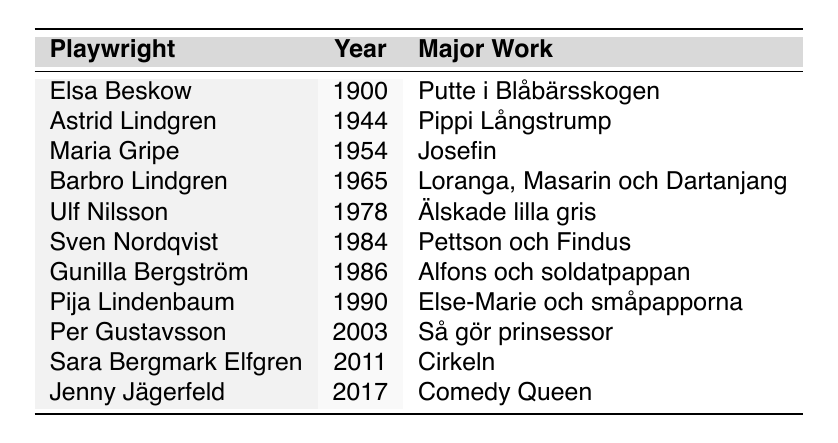What year did Elsa Beskow publish her major work? Referring to the table, Elsa Beskow published "Putte i Blåbärsskogen" in 1900.
Answer: 1900 Who wrote "Cirkeln" and in what year? The table indicates that "Cirkeln" was written by Sara Bergmark Elfgren in 2011.
Answer: Sara Bergmark Elfgren, 2011 How many playwrights have works published before 1980? By counting the entries in the table, the playwrights with works published before 1980 are: Elsa Beskow, Astrid Lindgren, Maria Gripe, Barbro Lindgren, and Ulf Nilsson, totaling 5 playwrights.
Answer: 5 Which playwright is associated with the book "Älskade lilla gris"? The table shows that Ulf Nilsson is the playwright associated with "Älskade lilla gris."
Answer: Ulf Nilsson Is "Pippi Långstrump" the major work of a playwright from the 1950s? The table lists "Pippi Långstrump" as the major work of Astrid Lindgren, who published it in 1944, which is not in the 1950s. Therefore, the statement is false.
Answer: No What is the difference in years between the works of Barbro Lindgren and Jenny Jägerfeld? Barbro Lindgren's major work was published in 1965 and Jenny Jägerfeld's work in 2017. The difference is 2017 - 1965 = 52 years.
Answer: 52 How many major works were published after the year 2000? The table shows that Per Gustavsson (2003), Sara Bergmark Elfgren (2011), and Jenny Jägerfeld (2017) published after 2000, totaling 3 major works.
Answer: 3 Which playwright has the most recent major work listed in the table? Analyzing the table, Jenny Jägerfeld's "Comedy Queen," published in 2017, is the most recent work mentioned.
Answer: Jenny Jägerfeld List the names of playwrights whose works were published in the 1980s. The table indicates that Sven Nordqvist (1984) and Gunilla Bergström (1986) published their works in the 1980s.
Answer: Sven Nordqvist, Gunilla Bergström What is the earliest year listed for major works in the table? The earliest year in the table is 1900, associated with Elsa Beskow's work.
Answer: 1900 Which of the listed works came out first, "Pippi Långstrump" or "Josefin"? The table reveals that "Pippi Långstrump" was published in 1944 and "Josefin" in 1954, so "Pippi Långstrump" came first.
Answer: Pippi Långstrump 